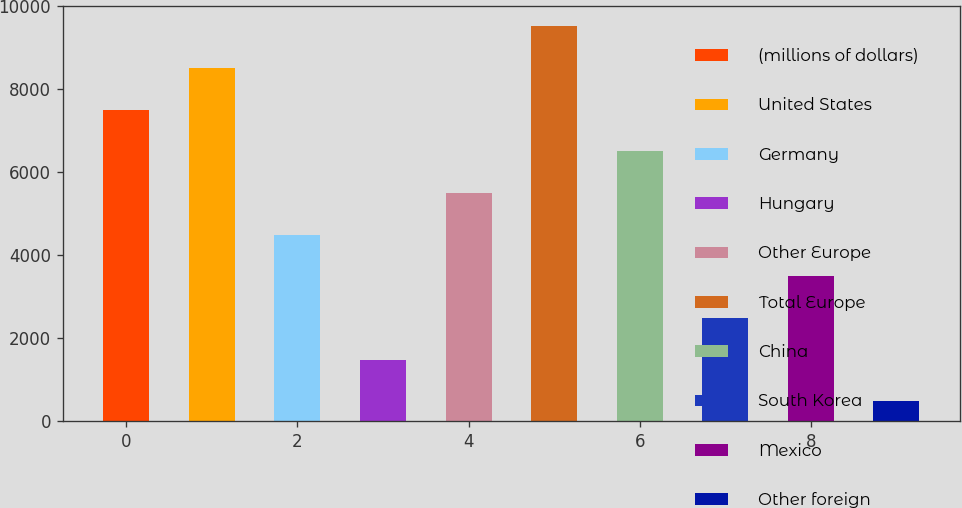Convert chart to OTSL. <chart><loc_0><loc_0><loc_500><loc_500><bar_chart><fcel>(millions of dollars)<fcel>United States<fcel>Germany<fcel>Hungary<fcel>Other Europe<fcel>Total Europe<fcel>China<fcel>South Korea<fcel>Mexico<fcel>Other foreign<nl><fcel>7513.49<fcel>8518.86<fcel>4497.38<fcel>1481.27<fcel>5502.75<fcel>9524.23<fcel>6508.12<fcel>2486.64<fcel>3492.01<fcel>475.9<nl></chart> 